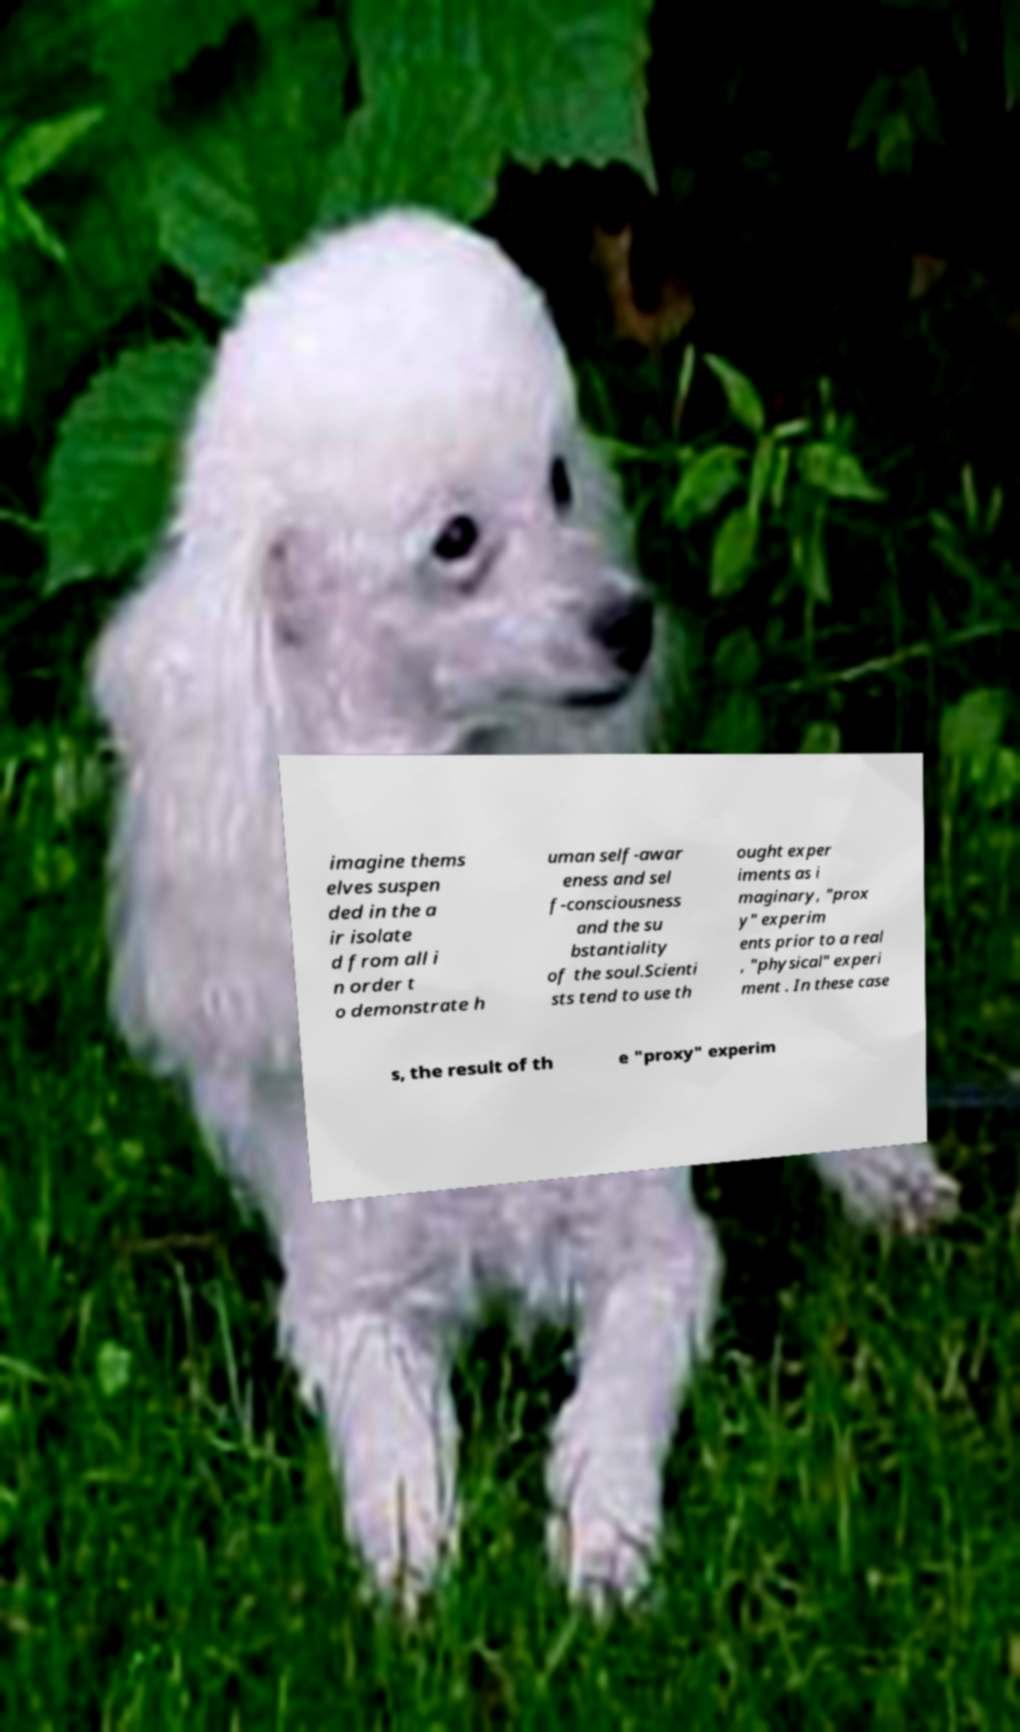Could you assist in decoding the text presented in this image and type it out clearly? imagine thems elves suspen ded in the a ir isolate d from all i n order t o demonstrate h uman self-awar eness and sel f-consciousness and the su bstantiality of the soul.Scienti sts tend to use th ought exper iments as i maginary, "prox y" experim ents prior to a real , "physical" experi ment . In these case s, the result of th e "proxy" experim 